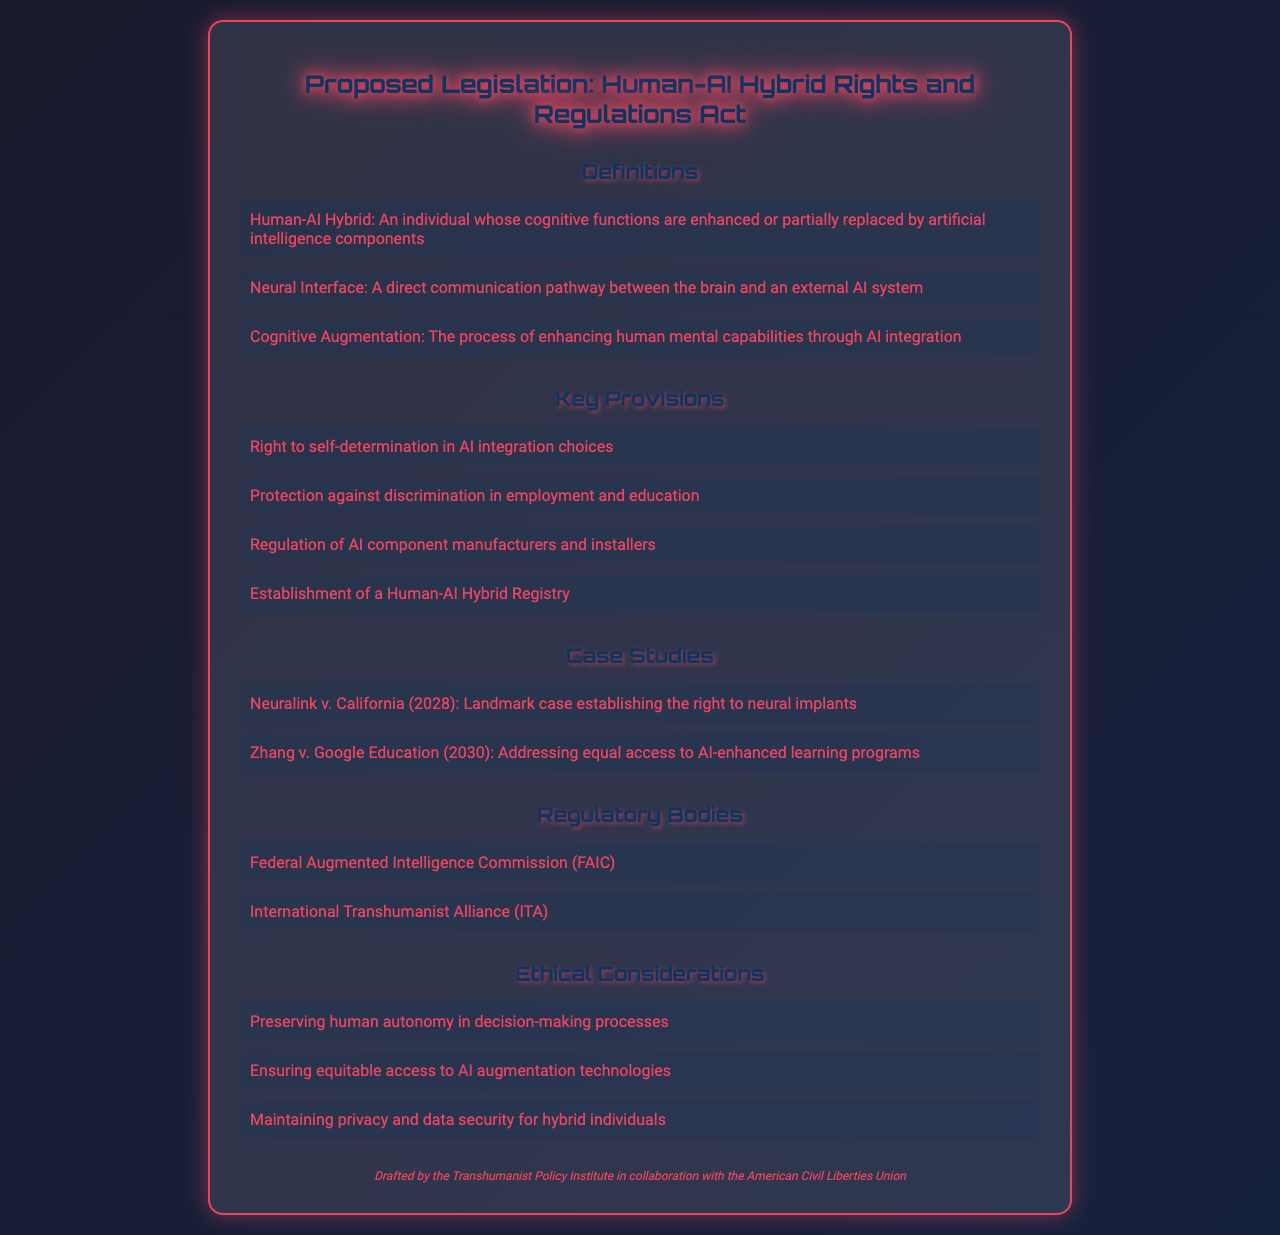What is the title of the proposed legislation? The title of the proposed legislation is explicitly stated at the beginning of the document.
Answer: Human-AI Hybrid Rights and Regulations Act What is the definition of a Human-AI Hybrid? The definition of a Human-AI Hybrid is mentioned under the Definitions section of the document.
Answer: An individual whose cognitive functions are enhanced or partially replaced by artificial intelligence components Which body is responsible for regulating AI component manufacturers? This information is outlined in the Key Provisions section, specifying the regulations for manufacturers.
Answer: Regulation of AI component manufacturers and installers What year was the case Neuralink v. California decided? The year of the case is found in the Case Studies section of the document, providing important legal precedents.
Answer: 2028 What protection is granted against discrimination? The specific protection is detailed in the Key Provisions section, addressing discrimination in different areas.
Answer: Protection against discrimination in employment and education Which organization is mentioned as part of regulatory bodies? This information is found under the Regulatory Bodies section, listing the overseeing organizations.
Answer: Federal Augmented Intelligence Commission What is one ethical consideration mentioned in the document? Ethical considerations are listed, highlighting the important aspects of human-AI hybrid integration.
Answer: Preserving human autonomy in decision-making processes What is the purpose of the Human-AI Hybrid Registry? The purpose of the registry can be inferred from the context of the Key Provisions section, as it aims to manage records.
Answer: Establishment of a Human-AI Hybrid Registry Which two organizations collaborated on drafting this document? The document specifies the collaborating organizations in the footer, which is crucial for understanding the authorship.
Answer: Transhumanist Policy Institute and American Civil Liberties Union 